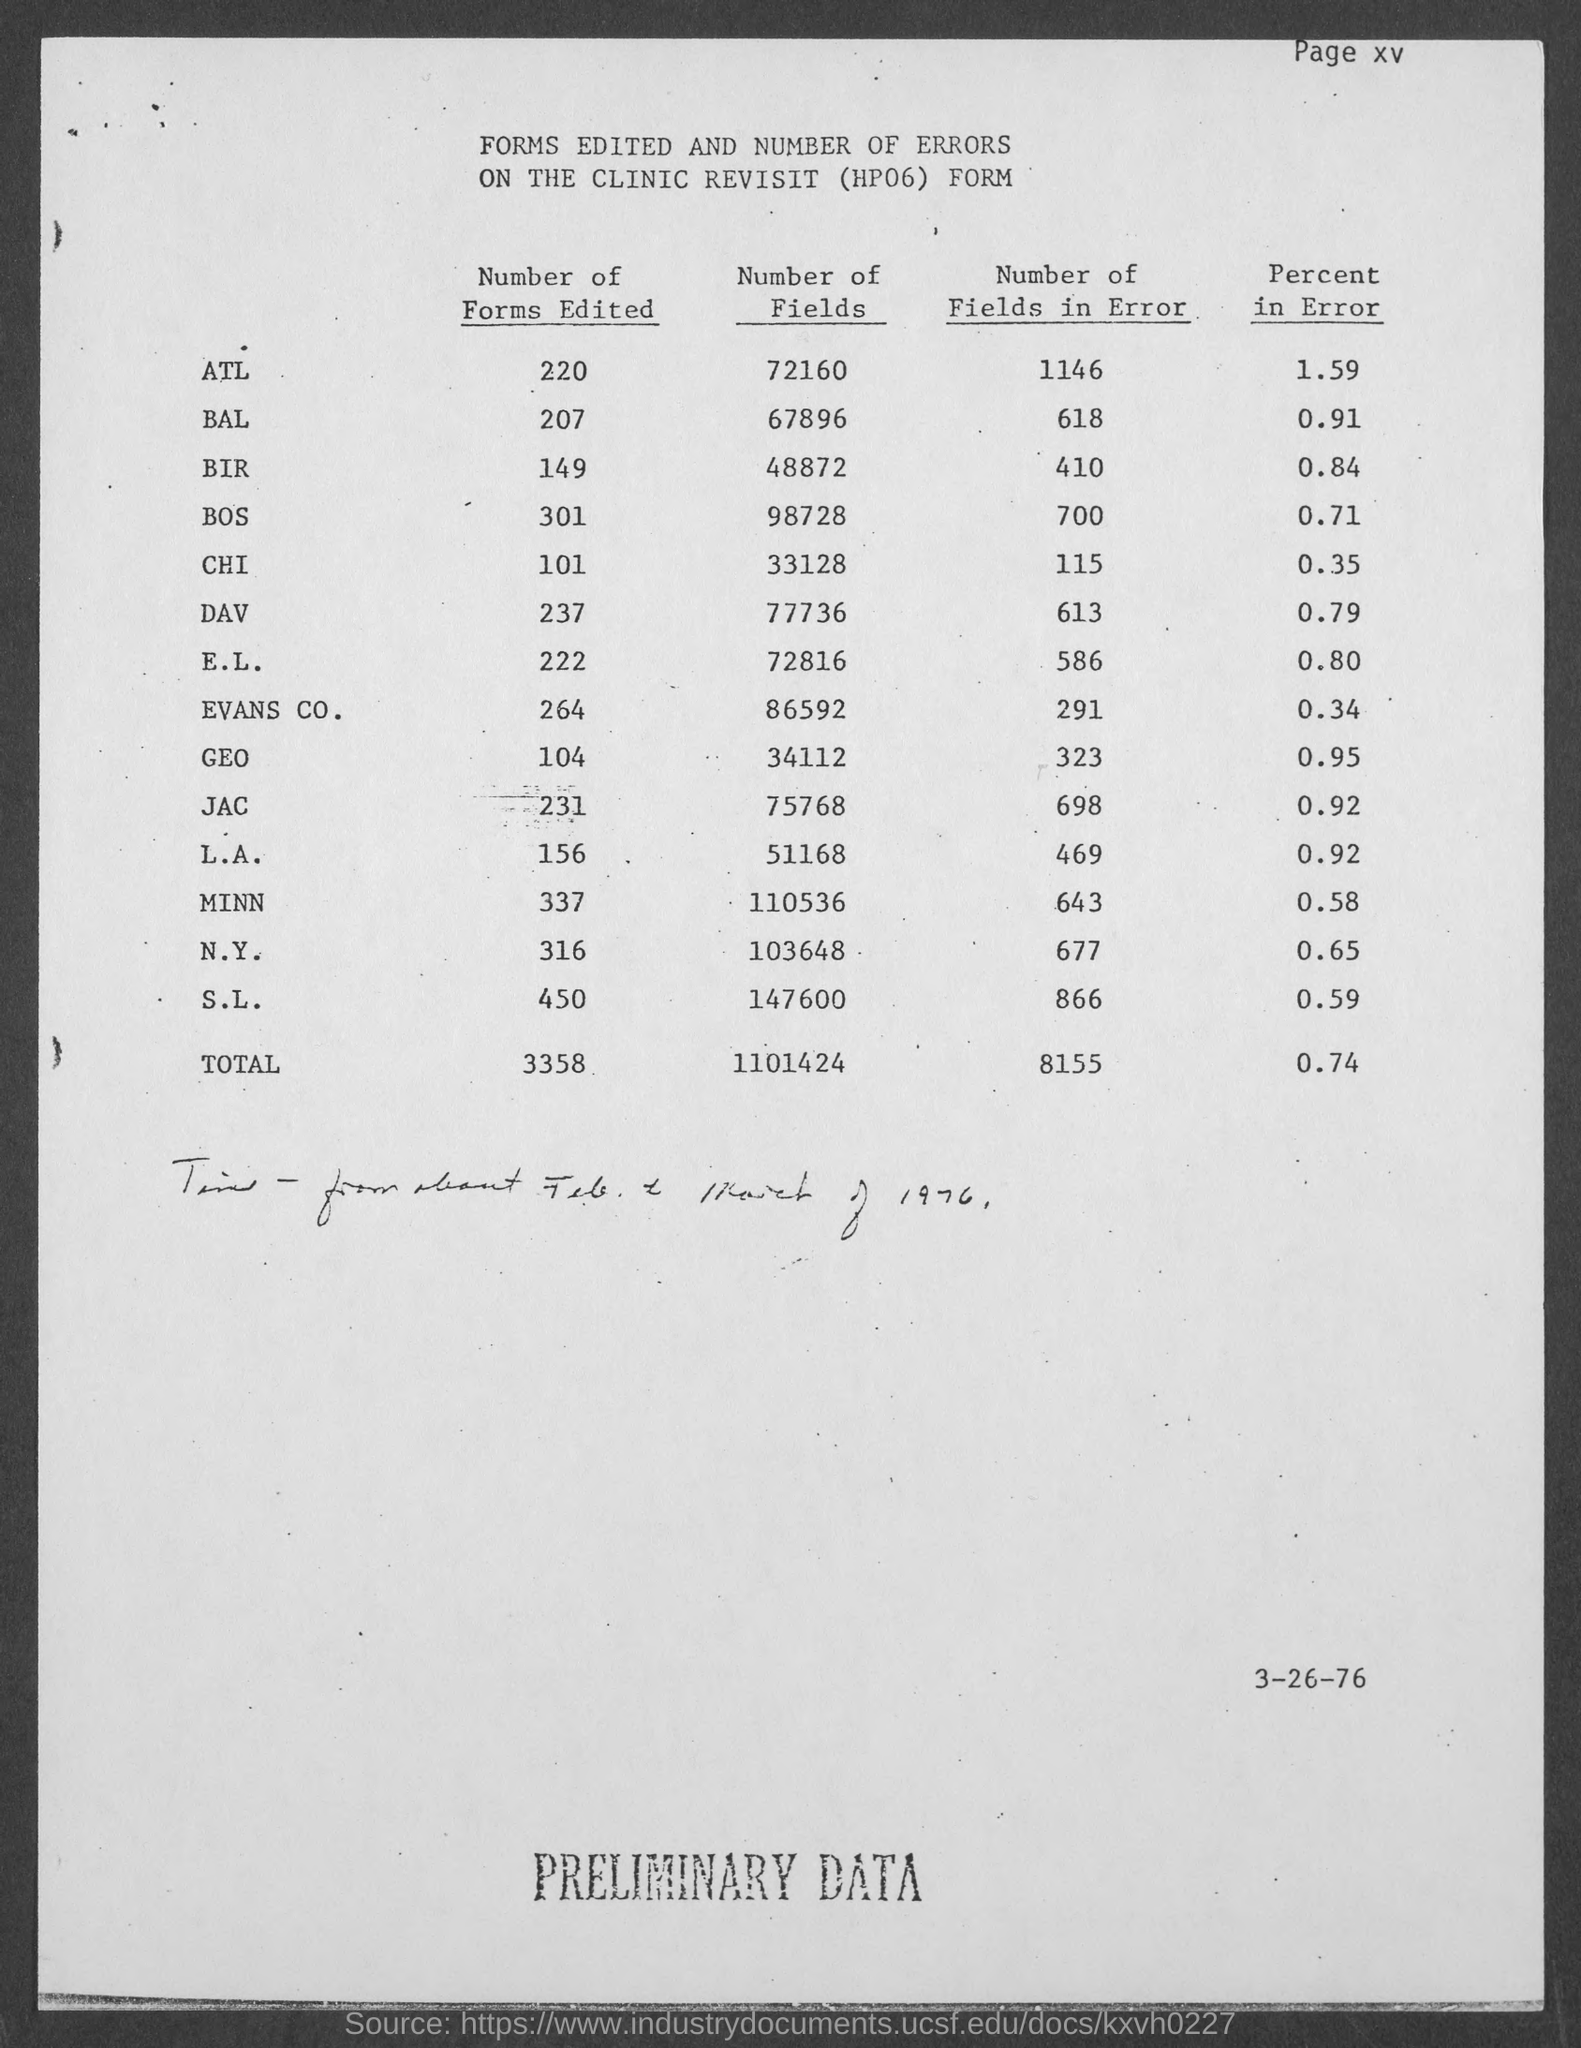What is the title of the table?
Your answer should be compact. Forms edited and number of errors on the clinic revisit (hp06) form. What is the total number of forms edited?
Give a very brief answer. 3358. What is the total number of fields?
Keep it short and to the point. 1101424. What is the total number of fields in error?
Give a very brief answer. 8155. What is the total percent in error?
Your response must be concise. 0.74. How many ATL forms are edited?
Your answer should be very brief. 220. How many BAL forms are edited?
Offer a terse response. 207. How many BIR forms are edited?
Offer a very short reply. 149. How many BOS forms are edited?
Keep it short and to the point. 301. What is the heading of last coulmn?
Your answer should be very brief. Percent in error. 